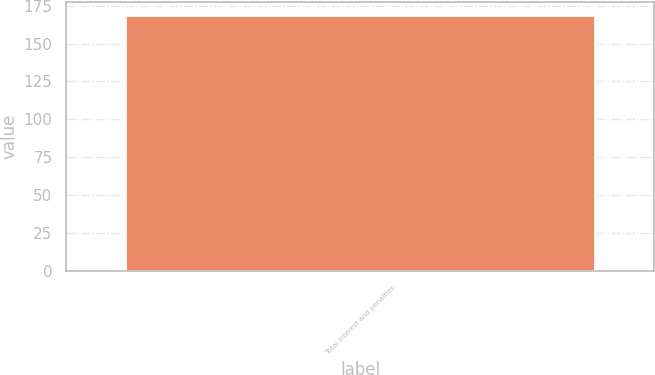Convert chart to OTSL. <chart><loc_0><loc_0><loc_500><loc_500><bar_chart><fcel>Total interest and penalties<nl><fcel>169<nl></chart> 